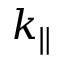Convert formula to latex. <formula><loc_0><loc_0><loc_500><loc_500>k _ { \| }</formula> 